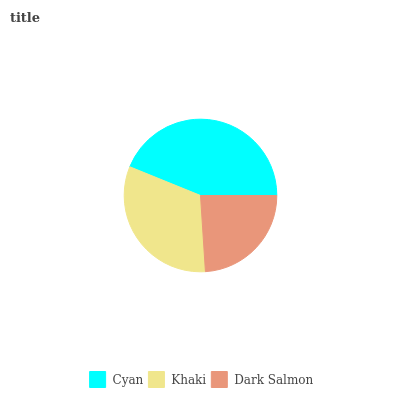Is Dark Salmon the minimum?
Answer yes or no. Yes. Is Cyan the maximum?
Answer yes or no. Yes. Is Khaki the minimum?
Answer yes or no. No. Is Khaki the maximum?
Answer yes or no. No. Is Cyan greater than Khaki?
Answer yes or no. Yes. Is Khaki less than Cyan?
Answer yes or no. Yes. Is Khaki greater than Cyan?
Answer yes or no. No. Is Cyan less than Khaki?
Answer yes or no. No. Is Khaki the high median?
Answer yes or no. Yes. Is Khaki the low median?
Answer yes or no. Yes. Is Dark Salmon the high median?
Answer yes or no. No. Is Cyan the low median?
Answer yes or no. No. 